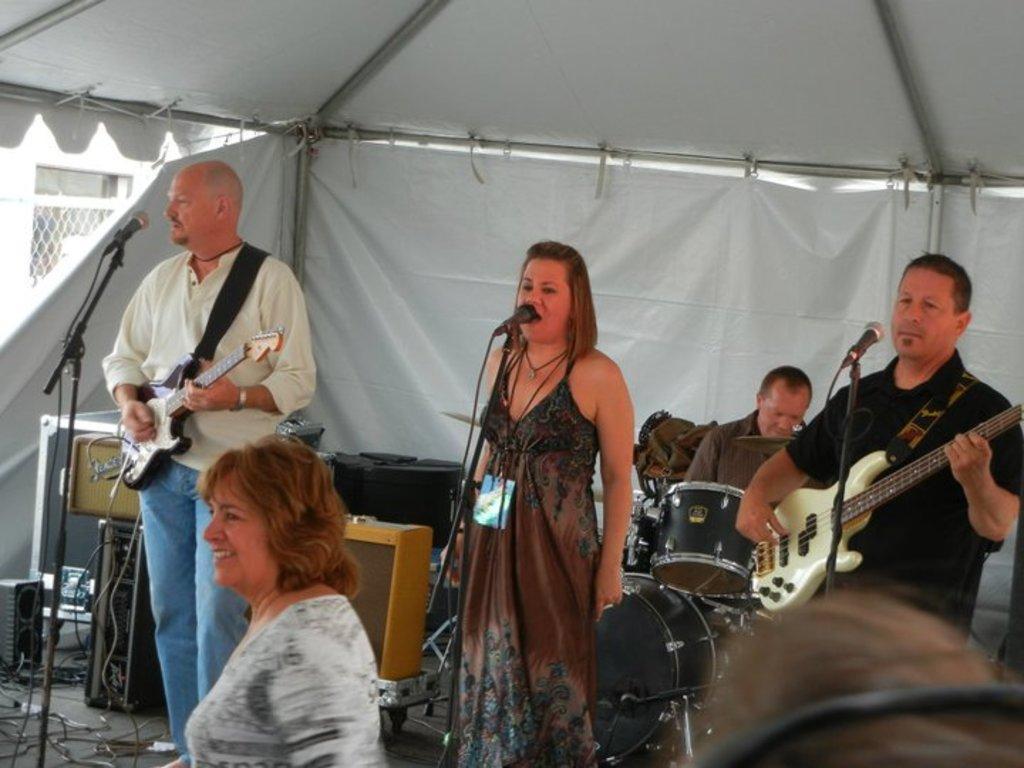How would you summarize this image in a sentence or two? In this image, we can see persons wearing clothes. There are two persons playing guitars in front of mics. There is a person in the middle of the image standing in front of the mic. There is a musical equipment and some musical instruments at the bottom of the image. 